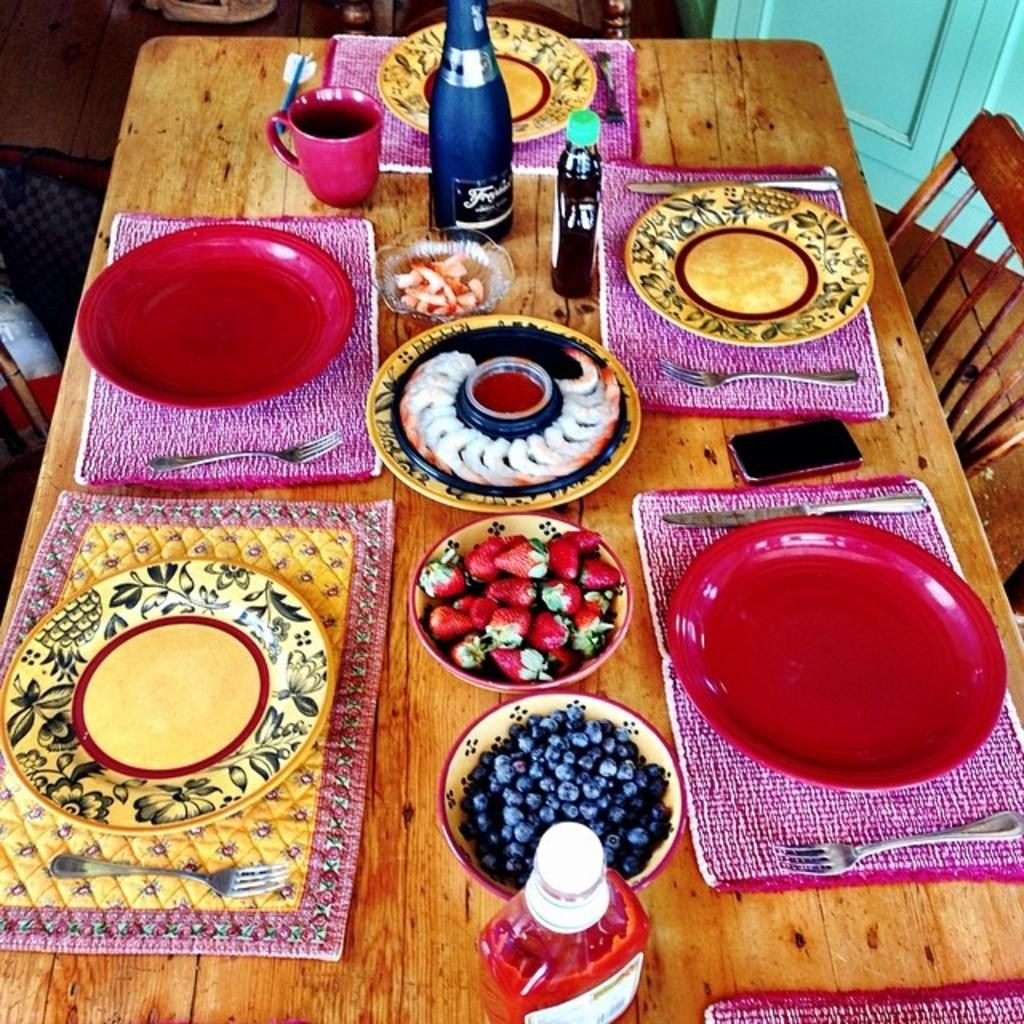What objects are present on the plates in the image? There is food on the plates in the image. How many bottles can be seen in the background? There are three bottles in the background. What type of furniture is visible in the image? There is a chair in the image. What architectural feature is present in the image? There is a door in the image. What type of linen is draped over the food on the plates? There is no linen present in the image; the food is directly on the plates. 